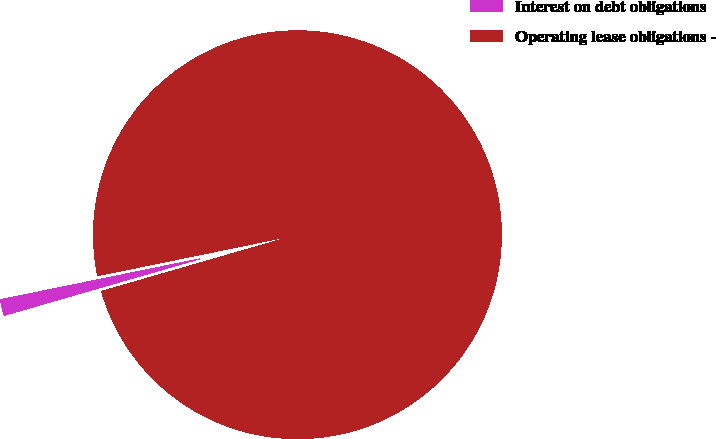Convert chart. <chart><loc_0><loc_0><loc_500><loc_500><pie_chart><fcel>Interest on debt obligations<fcel>Operating lease obligations -<nl><fcel>1.26%<fcel>98.74%<nl></chart> 